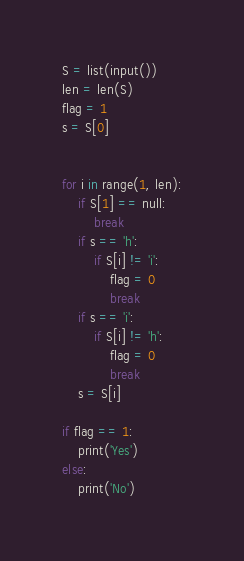<code> <loc_0><loc_0><loc_500><loc_500><_Python_>S = list(input())
len = len(S)
flag = 1
s = S[0]


for i in range(1, len):
    if S[1] == null:
        break
    if s == 'h':
        if S[i] != 'i':
            flag = 0
            break
    if s == 'i':
        if S[i] != 'h':
            flag = 0
            break
    s = S[i]

if flag == 1:
    print('Yes')
else:
    print('No')
</code> 